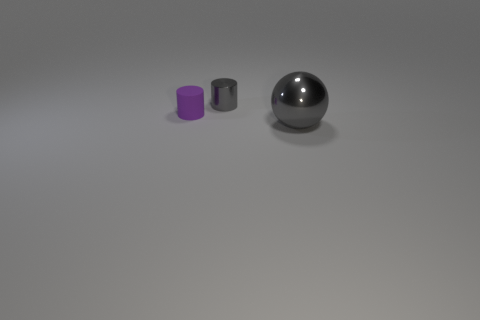There is a small thing that is behind the tiny purple rubber object; is its color the same as the big metallic thing?
Give a very brief answer. Yes. What is the size of the object that is behind the small thing in front of the tiny gray metal cylinder?
Offer a terse response. Small. There is another thing that is the same size as the purple rubber object; what is it made of?
Offer a very short reply. Metal. What number of other things are there of the same size as the gray metallic cylinder?
Provide a succinct answer. 1. How many balls are either shiny objects or big green shiny things?
Give a very brief answer. 1. Are there any other things that have the same material as the big gray sphere?
Ensure brevity in your answer.  Yes. What material is the gray object on the left side of the big gray thing in front of the small cylinder that is in front of the tiny gray metallic cylinder?
Your answer should be very brief. Metal. What is the material of the tiny object that is the same color as the ball?
Ensure brevity in your answer.  Metal. How many objects are made of the same material as the big ball?
Make the answer very short. 1. Is the size of the cylinder that is in front of the gray cylinder the same as the small metallic object?
Provide a short and direct response. Yes. 